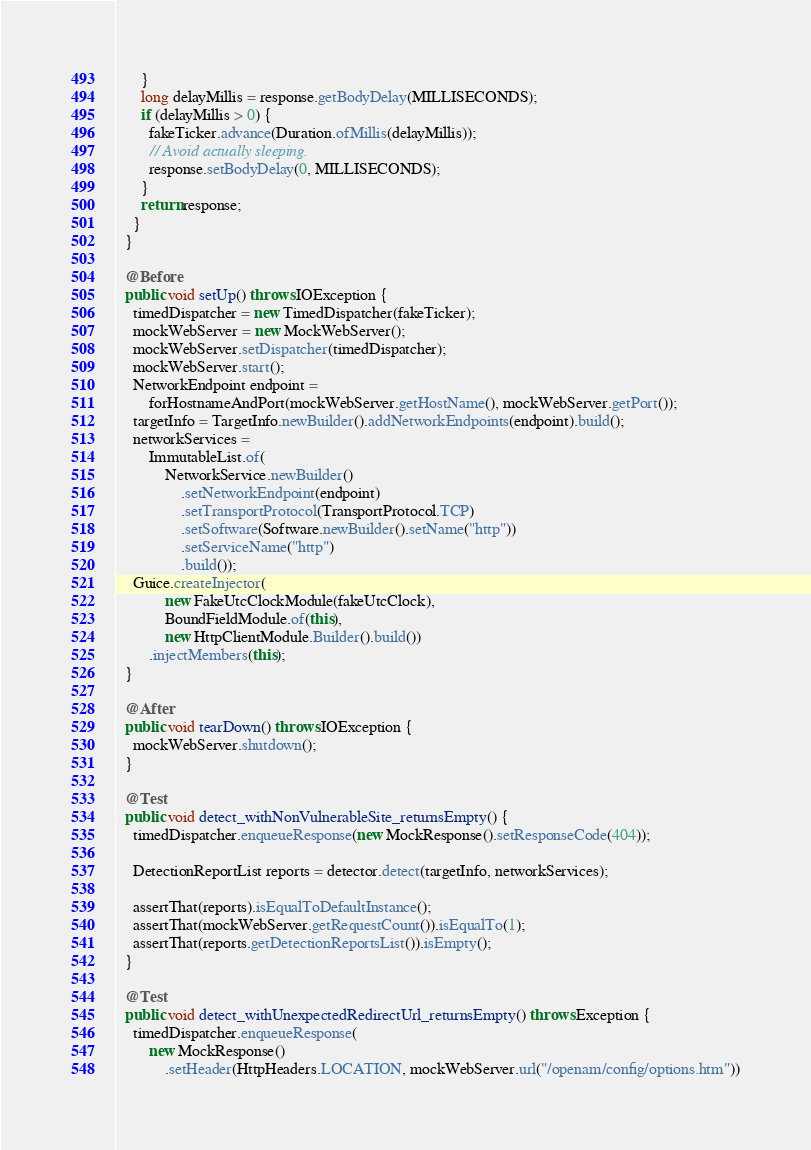Convert code to text. <code><loc_0><loc_0><loc_500><loc_500><_Java_>      }
      long delayMillis = response.getBodyDelay(MILLISECONDS);
      if (delayMillis > 0) {
        fakeTicker.advance(Duration.ofMillis(delayMillis));
        // Avoid actually sleeping.
        response.setBodyDelay(0, MILLISECONDS);
      }
      return response;
    }
  }

  @Before
  public void setUp() throws IOException {
    timedDispatcher = new TimedDispatcher(fakeTicker);
    mockWebServer = new MockWebServer();
    mockWebServer.setDispatcher(timedDispatcher);
    mockWebServer.start();
    NetworkEndpoint endpoint =
        forHostnameAndPort(mockWebServer.getHostName(), mockWebServer.getPort());
    targetInfo = TargetInfo.newBuilder().addNetworkEndpoints(endpoint).build();
    networkServices =
        ImmutableList.of(
            NetworkService.newBuilder()
                .setNetworkEndpoint(endpoint)
                .setTransportProtocol(TransportProtocol.TCP)
                .setSoftware(Software.newBuilder().setName("http"))
                .setServiceName("http")
                .build());
    Guice.createInjector(
            new FakeUtcClockModule(fakeUtcClock),
            BoundFieldModule.of(this),
            new HttpClientModule.Builder().build())
        .injectMembers(this);
  }

  @After
  public void tearDown() throws IOException {
    mockWebServer.shutdown();
  }

  @Test
  public void detect_withNonVulnerableSite_returnsEmpty() {
    timedDispatcher.enqueueResponse(new MockResponse().setResponseCode(404));

    DetectionReportList reports = detector.detect(targetInfo, networkServices);

    assertThat(reports).isEqualToDefaultInstance();
    assertThat(mockWebServer.getRequestCount()).isEqualTo(1);
    assertThat(reports.getDetectionReportsList()).isEmpty();
  }

  @Test
  public void detect_withUnexpectedRedirectUrl_returnsEmpty() throws Exception {
    timedDispatcher.enqueueResponse(
        new MockResponse()
            .setHeader(HttpHeaders.LOCATION, mockWebServer.url("/openam/config/options.htm"))</code> 